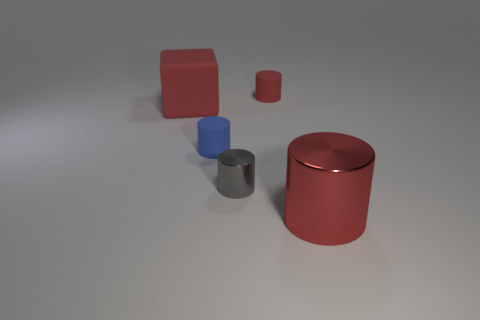Subtract all red cylinders. How many were subtracted if there are1red cylinders left? 1 Subtract all red metallic cylinders. How many cylinders are left? 3 Subtract all gray blocks. How many red cylinders are left? 2 Subtract all gray cylinders. How many cylinders are left? 3 Add 3 small cubes. How many objects exist? 8 Subtract all cylinders. How many objects are left? 1 Subtract all gray cylinders. Subtract all green blocks. How many cylinders are left? 3 Subtract all blue matte cubes. Subtract all big metal cylinders. How many objects are left? 4 Add 1 tiny gray cylinders. How many tiny gray cylinders are left? 2 Add 4 tiny gray rubber cylinders. How many tiny gray rubber cylinders exist? 4 